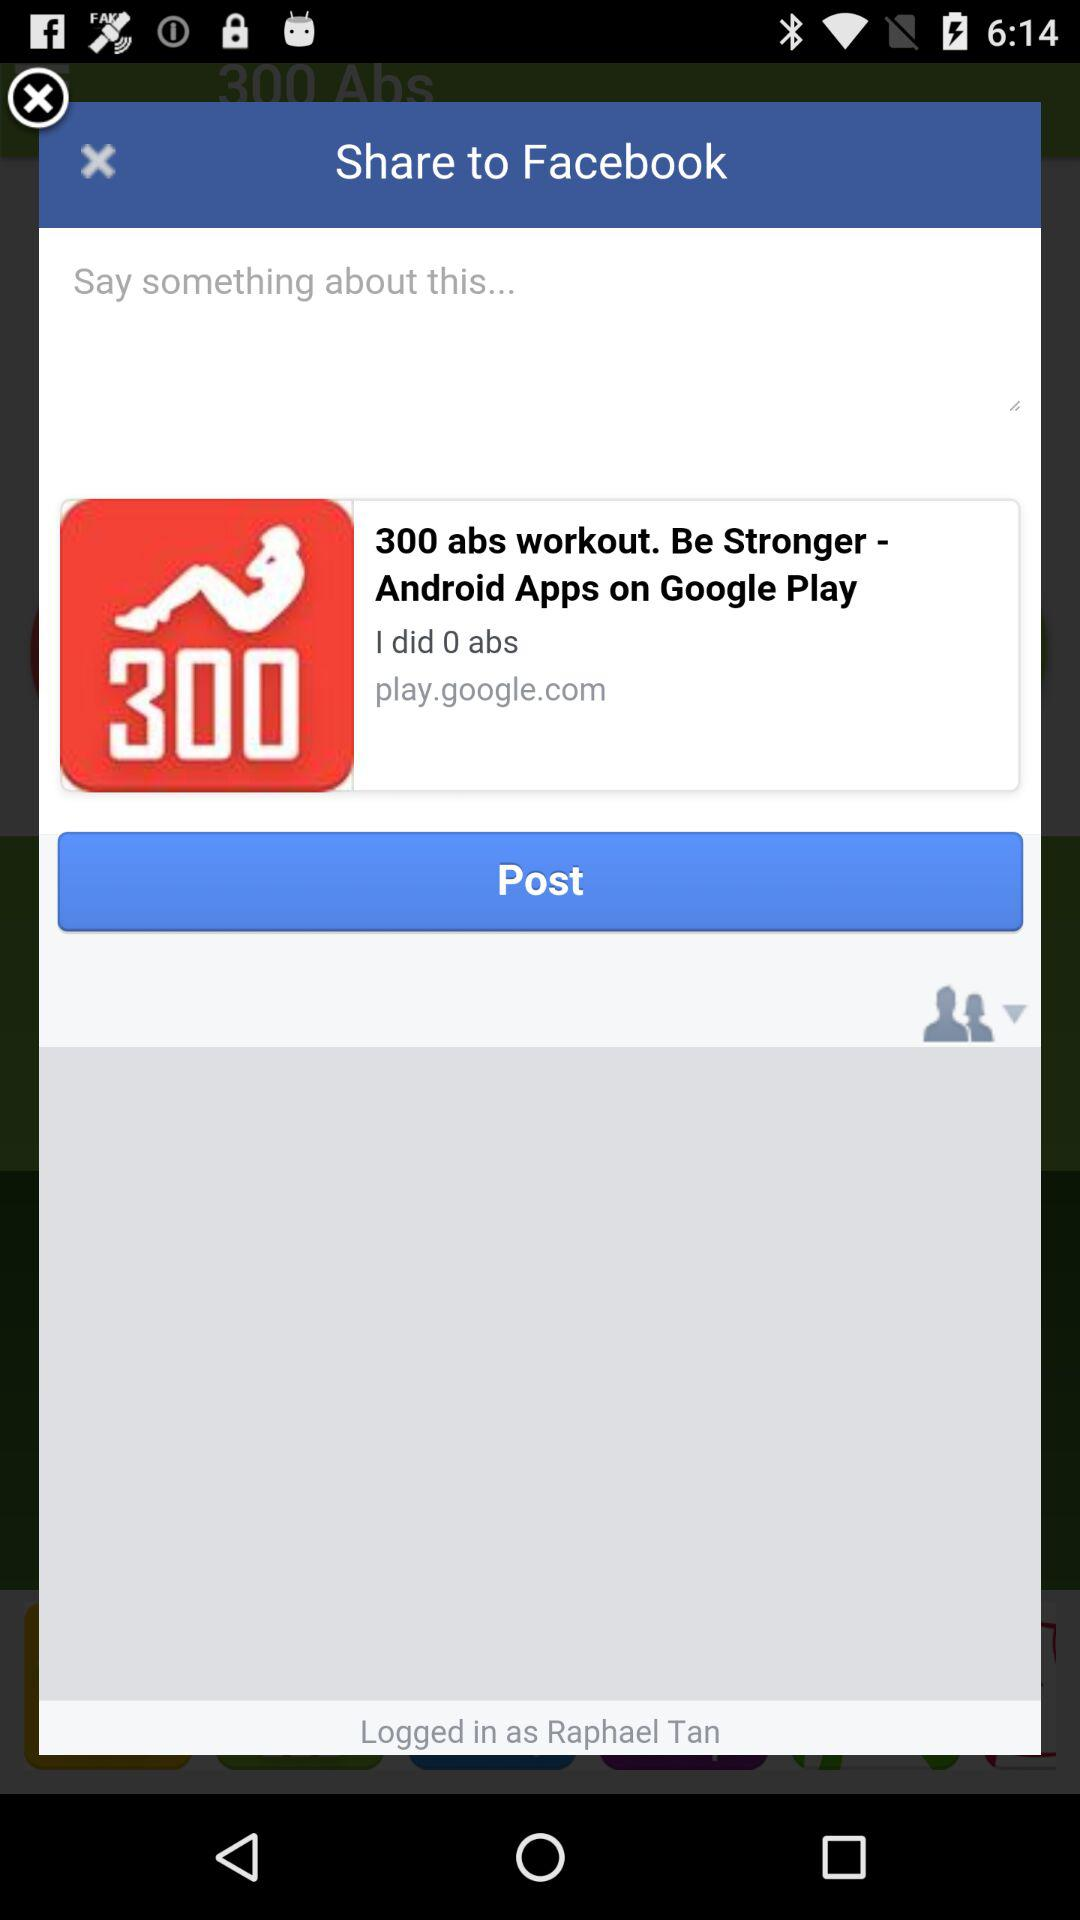What is the logged in name? The logged in name is Raphael Tan. 